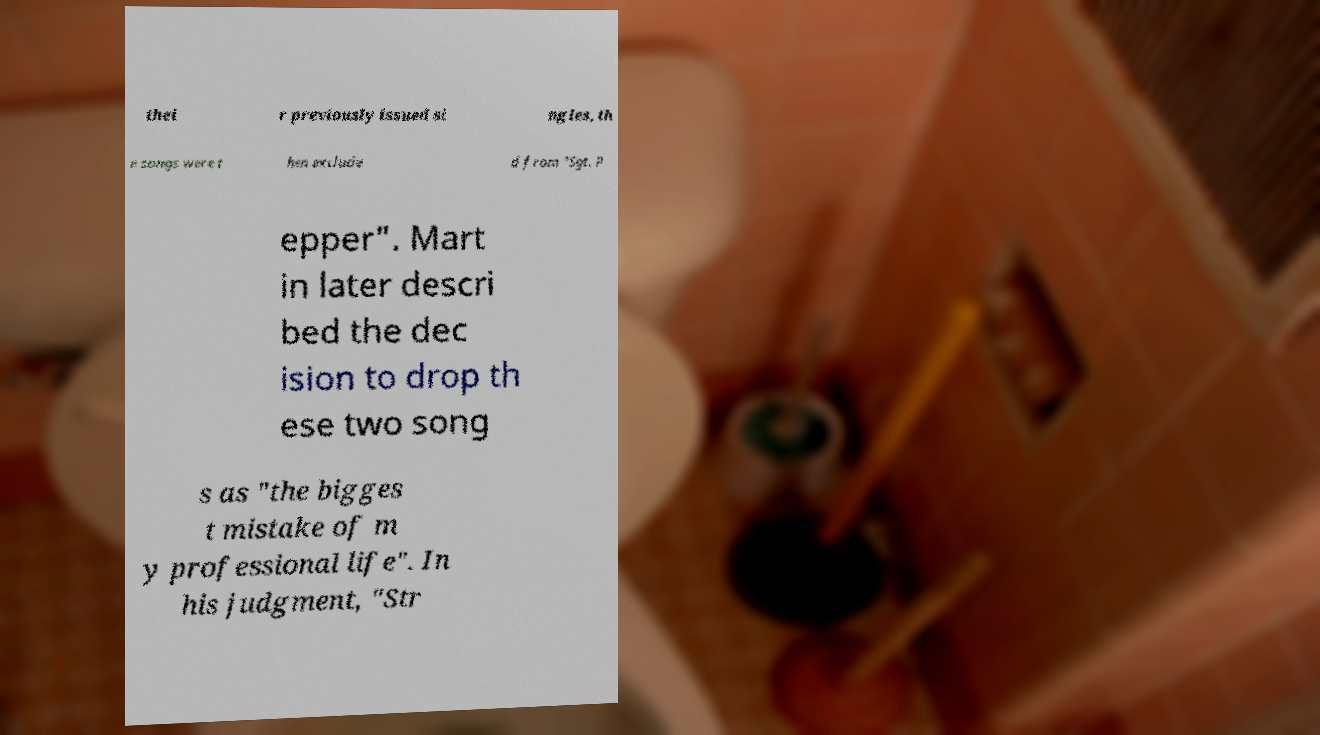Could you extract and type out the text from this image? thei r previously issued si ngles, th e songs were t hen exclude d from "Sgt. P epper". Mart in later descri bed the dec ision to drop th ese two song s as "the bigges t mistake of m y professional life". In his judgment, "Str 